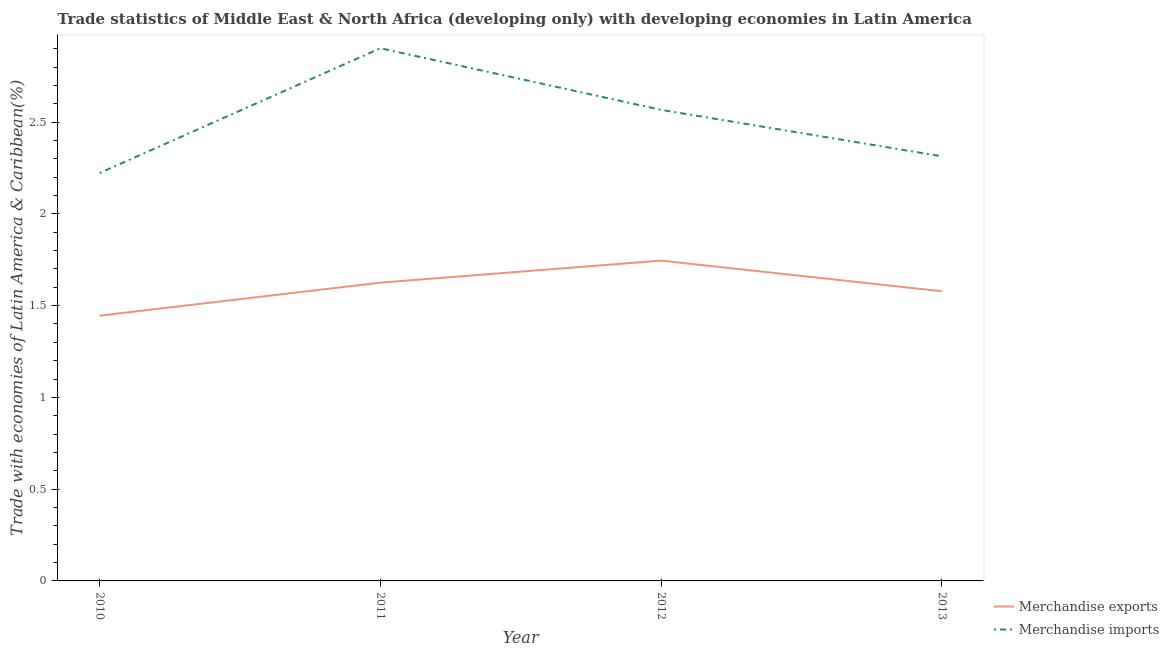How many different coloured lines are there?
Keep it short and to the point. 2. Is the number of lines equal to the number of legend labels?
Offer a terse response. Yes. What is the merchandise imports in 2013?
Make the answer very short. 2.31. Across all years, what is the maximum merchandise exports?
Your response must be concise. 1.75. Across all years, what is the minimum merchandise exports?
Your answer should be very brief. 1.45. In which year was the merchandise imports maximum?
Offer a very short reply. 2011. In which year was the merchandise exports minimum?
Keep it short and to the point. 2010. What is the total merchandise exports in the graph?
Keep it short and to the point. 6.39. What is the difference between the merchandise exports in 2012 and that in 2013?
Offer a terse response. 0.17. What is the difference between the merchandise exports in 2010 and the merchandise imports in 2011?
Make the answer very short. -1.46. What is the average merchandise imports per year?
Your answer should be compact. 2.5. In the year 2011, what is the difference between the merchandise exports and merchandise imports?
Ensure brevity in your answer.  -1.28. What is the ratio of the merchandise exports in 2012 to that in 2013?
Your response must be concise. 1.11. Is the difference between the merchandise exports in 2010 and 2012 greater than the difference between the merchandise imports in 2010 and 2012?
Your response must be concise. Yes. What is the difference between the highest and the second highest merchandise imports?
Keep it short and to the point. 0.34. What is the difference between the highest and the lowest merchandise imports?
Give a very brief answer. 0.68. In how many years, is the merchandise exports greater than the average merchandise exports taken over all years?
Provide a succinct answer. 2. Is the sum of the merchandise exports in 2011 and 2013 greater than the maximum merchandise imports across all years?
Your response must be concise. Yes. How many lines are there?
Keep it short and to the point. 2. How many years are there in the graph?
Give a very brief answer. 4. What is the difference between two consecutive major ticks on the Y-axis?
Give a very brief answer. 0.5. Are the values on the major ticks of Y-axis written in scientific E-notation?
Offer a very short reply. No. Does the graph contain any zero values?
Make the answer very short. No. How many legend labels are there?
Provide a succinct answer. 2. What is the title of the graph?
Your response must be concise. Trade statistics of Middle East & North Africa (developing only) with developing economies in Latin America. What is the label or title of the X-axis?
Make the answer very short. Year. What is the label or title of the Y-axis?
Keep it short and to the point. Trade with economies of Latin America & Caribbean(%). What is the Trade with economies of Latin America & Caribbean(%) in Merchandise exports in 2010?
Your answer should be compact. 1.45. What is the Trade with economies of Latin America & Caribbean(%) in Merchandise imports in 2010?
Keep it short and to the point. 2.22. What is the Trade with economies of Latin America & Caribbean(%) in Merchandise exports in 2011?
Offer a terse response. 1.63. What is the Trade with economies of Latin America & Caribbean(%) in Merchandise imports in 2011?
Keep it short and to the point. 2.9. What is the Trade with economies of Latin America & Caribbean(%) in Merchandise exports in 2012?
Give a very brief answer. 1.75. What is the Trade with economies of Latin America & Caribbean(%) in Merchandise imports in 2012?
Ensure brevity in your answer.  2.57. What is the Trade with economies of Latin America & Caribbean(%) in Merchandise exports in 2013?
Make the answer very short. 1.58. What is the Trade with economies of Latin America & Caribbean(%) of Merchandise imports in 2013?
Your answer should be compact. 2.31. Across all years, what is the maximum Trade with economies of Latin America & Caribbean(%) of Merchandise exports?
Your response must be concise. 1.75. Across all years, what is the maximum Trade with economies of Latin America & Caribbean(%) of Merchandise imports?
Provide a succinct answer. 2.9. Across all years, what is the minimum Trade with economies of Latin America & Caribbean(%) of Merchandise exports?
Offer a terse response. 1.45. Across all years, what is the minimum Trade with economies of Latin America & Caribbean(%) in Merchandise imports?
Your response must be concise. 2.22. What is the total Trade with economies of Latin America & Caribbean(%) of Merchandise exports in the graph?
Make the answer very short. 6.39. What is the total Trade with economies of Latin America & Caribbean(%) in Merchandise imports in the graph?
Provide a succinct answer. 10.01. What is the difference between the Trade with economies of Latin America & Caribbean(%) in Merchandise exports in 2010 and that in 2011?
Ensure brevity in your answer.  -0.18. What is the difference between the Trade with economies of Latin America & Caribbean(%) of Merchandise imports in 2010 and that in 2011?
Provide a short and direct response. -0.68. What is the difference between the Trade with economies of Latin America & Caribbean(%) of Merchandise exports in 2010 and that in 2012?
Provide a succinct answer. -0.3. What is the difference between the Trade with economies of Latin America & Caribbean(%) of Merchandise imports in 2010 and that in 2012?
Offer a terse response. -0.34. What is the difference between the Trade with economies of Latin America & Caribbean(%) of Merchandise exports in 2010 and that in 2013?
Ensure brevity in your answer.  -0.13. What is the difference between the Trade with economies of Latin America & Caribbean(%) of Merchandise imports in 2010 and that in 2013?
Offer a very short reply. -0.09. What is the difference between the Trade with economies of Latin America & Caribbean(%) of Merchandise exports in 2011 and that in 2012?
Offer a terse response. -0.12. What is the difference between the Trade with economies of Latin America & Caribbean(%) of Merchandise imports in 2011 and that in 2012?
Make the answer very short. 0.34. What is the difference between the Trade with economies of Latin America & Caribbean(%) in Merchandise exports in 2011 and that in 2013?
Your answer should be compact. 0.05. What is the difference between the Trade with economies of Latin America & Caribbean(%) in Merchandise imports in 2011 and that in 2013?
Your answer should be compact. 0.59. What is the difference between the Trade with economies of Latin America & Caribbean(%) in Merchandise exports in 2012 and that in 2013?
Your answer should be very brief. 0.17. What is the difference between the Trade with economies of Latin America & Caribbean(%) in Merchandise imports in 2012 and that in 2013?
Make the answer very short. 0.25. What is the difference between the Trade with economies of Latin America & Caribbean(%) of Merchandise exports in 2010 and the Trade with economies of Latin America & Caribbean(%) of Merchandise imports in 2011?
Keep it short and to the point. -1.46. What is the difference between the Trade with economies of Latin America & Caribbean(%) in Merchandise exports in 2010 and the Trade with economies of Latin America & Caribbean(%) in Merchandise imports in 2012?
Give a very brief answer. -1.12. What is the difference between the Trade with economies of Latin America & Caribbean(%) in Merchandise exports in 2010 and the Trade with economies of Latin America & Caribbean(%) in Merchandise imports in 2013?
Offer a very short reply. -0.87. What is the difference between the Trade with economies of Latin America & Caribbean(%) in Merchandise exports in 2011 and the Trade with economies of Latin America & Caribbean(%) in Merchandise imports in 2012?
Provide a succinct answer. -0.94. What is the difference between the Trade with economies of Latin America & Caribbean(%) in Merchandise exports in 2011 and the Trade with economies of Latin America & Caribbean(%) in Merchandise imports in 2013?
Provide a succinct answer. -0.69. What is the difference between the Trade with economies of Latin America & Caribbean(%) of Merchandise exports in 2012 and the Trade with economies of Latin America & Caribbean(%) of Merchandise imports in 2013?
Keep it short and to the point. -0.57. What is the average Trade with economies of Latin America & Caribbean(%) of Merchandise exports per year?
Your answer should be compact. 1.6. What is the average Trade with economies of Latin America & Caribbean(%) of Merchandise imports per year?
Ensure brevity in your answer.  2.5. In the year 2010, what is the difference between the Trade with economies of Latin America & Caribbean(%) in Merchandise exports and Trade with economies of Latin America & Caribbean(%) in Merchandise imports?
Give a very brief answer. -0.78. In the year 2011, what is the difference between the Trade with economies of Latin America & Caribbean(%) of Merchandise exports and Trade with economies of Latin America & Caribbean(%) of Merchandise imports?
Provide a short and direct response. -1.28. In the year 2012, what is the difference between the Trade with economies of Latin America & Caribbean(%) of Merchandise exports and Trade with economies of Latin America & Caribbean(%) of Merchandise imports?
Provide a succinct answer. -0.82. In the year 2013, what is the difference between the Trade with economies of Latin America & Caribbean(%) in Merchandise exports and Trade with economies of Latin America & Caribbean(%) in Merchandise imports?
Offer a terse response. -0.74. What is the ratio of the Trade with economies of Latin America & Caribbean(%) of Merchandise exports in 2010 to that in 2011?
Your answer should be compact. 0.89. What is the ratio of the Trade with economies of Latin America & Caribbean(%) of Merchandise imports in 2010 to that in 2011?
Ensure brevity in your answer.  0.77. What is the ratio of the Trade with economies of Latin America & Caribbean(%) of Merchandise exports in 2010 to that in 2012?
Your response must be concise. 0.83. What is the ratio of the Trade with economies of Latin America & Caribbean(%) in Merchandise imports in 2010 to that in 2012?
Make the answer very short. 0.87. What is the ratio of the Trade with economies of Latin America & Caribbean(%) of Merchandise exports in 2010 to that in 2013?
Make the answer very short. 0.92. What is the ratio of the Trade with economies of Latin America & Caribbean(%) in Merchandise imports in 2010 to that in 2013?
Provide a succinct answer. 0.96. What is the ratio of the Trade with economies of Latin America & Caribbean(%) of Merchandise exports in 2011 to that in 2012?
Keep it short and to the point. 0.93. What is the ratio of the Trade with economies of Latin America & Caribbean(%) of Merchandise imports in 2011 to that in 2012?
Give a very brief answer. 1.13. What is the ratio of the Trade with economies of Latin America & Caribbean(%) of Merchandise exports in 2011 to that in 2013?
Give a very brief answer. 1.03. What is the ratio of the Trade with economies of Latin America & Caribbean(%) in Merchandise imports in 2011 to that in 2013?
Make the answer very short. 1.25. What is the ratio of the Trade with economies of Latin America & Caribbean(%) in Merchandise exports in 2012 to that in 2013?
Make the answer very short. 1.11. What is the ratio of the Trade with economies of Latin America & Caribbean(%) of Merchandise imports in 2012 to that in 2013?
Your answer should be very brief. 1.11. What is the difference between the highest and the second highest Trade with economies of Latin America & Caribbean(%) of Merchandise exports?
Your response must be concise. 0.12. What is the difference between the highest and the second highest Trade with economies of Latin America & Caribbean(%) in Merchandise imports?
Keep it short and to the point. 0.34. What is the difference between the highest and the lowest Trade with economies of Latin America & Caribbean(%) of Merchandise exports?
Provide a short and direct response. 0.3. What is the difference between the highest and the lowest Trade with economies of Latin America & Caribbean(%) in Merchandise imports?
Ensure brevity in your answer.  0.68. 